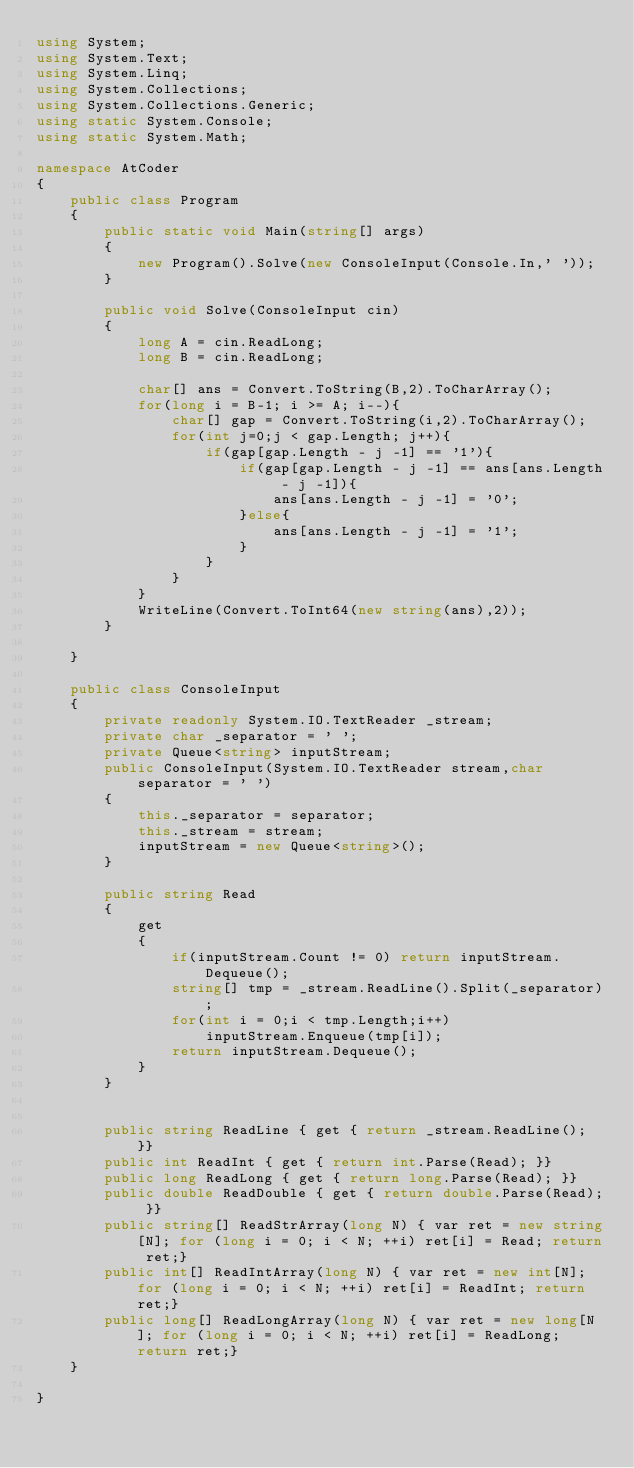<code> <loc_0><loc_0><loc_500><loc_500><_C#_>using System;
using System.Text;
using System.Linq;
using System.Collections;
using System.Collections.Generic;
using static System.Console;
using static System.Math;

namespace AtCoder
{
    public class Program
    {
        public static void Main(string[] args)
        {
            new Program().Solve(new ConsoleInput(Console.In,' '));
        }

        public void Solve(ConsoleInput cin)
        {
            long A = cin.ReadLong;
            long B = cin.ReadLong;

            char[] ans = Convert.ToString(B,2).ToCharArray();
            for(long i = B-1; i >= A; i--){
                char[] gap = Convert.ToString(i,2).ToCharArray();
                for(int j=0;j < gap.Length; j++){
                    if(gap[gap.Length - j -1] == '1'){
                        if(gap[gap.Length - j -1] == ans[ans.Length - j -1]){
                            ans[ans.Length - j -1] = '0';
                        }else{
                            ans[ans.Length - j -1] = '1';
                        }
                    }
                }
            }
            WriteLine(Convert.ToInt64(new string(ans),2));
        }

    }

    public class ConsoleInput
    {
        private readonly System.IO.TextReader _stream;
        private char _separator = ' ';
        private Queue<string> inputStream;
        public ConsoleInput(System.IO.TextReader stream,char separator = ' ')
        {
            this._separator = separator;
            this._stream = stream;
            inputStream = new Queue<string>();
        }

        public string Read
        {
            get
            {
                if(inputStream.Count != 0) return inputStream.Dequeue();
                string[] tmp = _stream.ReadLine().Split(_separator);
                for(int i = 0;i < tmp.Length;i++)
                    inputStream.Enqueue(tmp[i]);
                return inputStream.Dequeue();
            }
        }

        
        public string ReadLine { get { return _stream.ReadLine(); }}
        public int ReadInt { get { return int.Parse(Read); }}
        public long ReadLong { get { return long.Parse(Read); }}
        public double ReadDouble { get { return double.Parse(Read); }}
        public string[] ReadStrArray(long N) { var ret = new string[N]; for (long i = 0; i < N; ++i) ret[i] = Read; return ret;}
        public int[] ReadIntArray(long N) { var ret = new int[N]; for (long i = 0; i < N; ++i) ret[i] = ReadInt; return ret;}
        public long[] ReadLongArray(long N) { var ret = new long[N]; for (long i = 0; i < N; ++i) ret[i] = ReadLong; return ret;}
    }

}</code> 